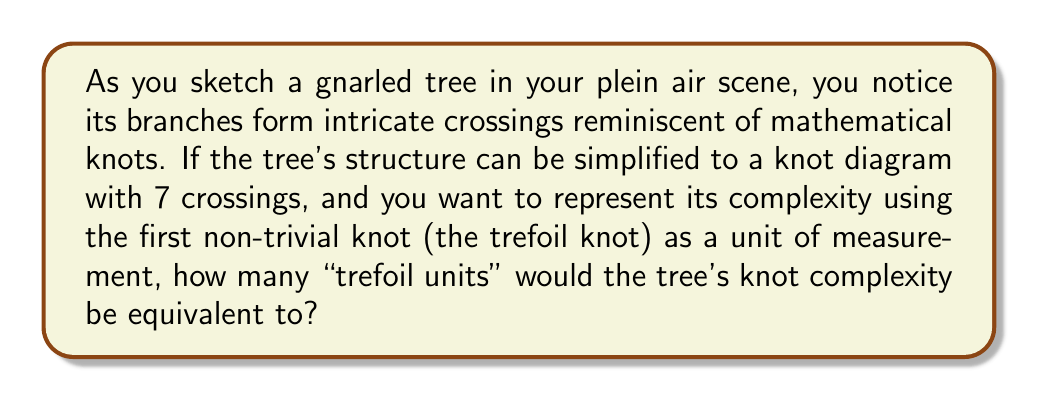What is the answer to this math problem? To solve this problem, we need to follow these steps:

1. Recall that the crossing number of a knot is the minimum number of crossings in any diagram of the knot.

2. The trefoil knot, which is the simplest non-trivial knot, has a crossing number of 3.

3. The tree's structure is simplified to a knot diagram with 7 crossings, so its crossing number is at most 7 (it could be less, but we'll assume 7 for this problem).

4. To express the tree's knot complexity in "trefoil units," we need to divide the tree's crossing number by the trefoil knot's crossing number:

   $$\text{Trefoil units} = \frac{\text{Tree's crossing number}}{\text{Trefoil knot's crossing number}} = \frac{7}{3}$$

5. Simplify the fraction:
   $$\frac{7}{3} \approx 2.33333...$$

6. Round to two decimal places for a more concise representation.

This approach allows us to quantify the complexity of natural forms in plein air scenes using knot theory, providing an interesting intersection between mathematics and art.
Answer: 2.33 trefoil units 